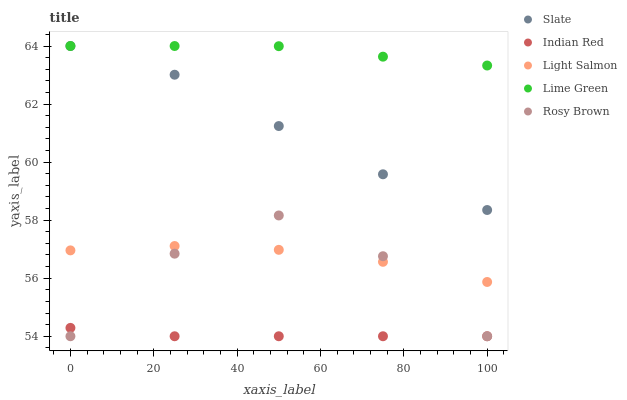Does Indian Red have the minimum area under the curve?
Answer yes or no. Yes. Does Lime Green have the maximum area under the curve?
Answer yes or no. Yes. Does Rosy Brown have the minimum area under the curve?
Answer yes or no. No. Does Rosy Brown have the maximum area under the curve?
Answer yes or no. No. Is Indian Red the smoothest?
Answer yes or no. Yes. Is Rosy Brown the roughest?
Answer yes or no. Yes. Is Lime Green the smoothest?
Answer yes or no. No. Is Lime Green the roughest?
Answer yes or no. No. Does Rosy Brown have the lowest value?
Answer yes or no. Yes. Does Lime Green have the lowest value?
Answer yes or no. No. Does Lime Green have the highest value?
Answer yes or no. Yes. Does Rosy Brown have the highest value?
Answer yes or no. No. Is Indian Red less than Lime Green?
Answer yes or no. Yes. Is Slate greater than Rosy Brown?
Answer yes or no. Yes. Does Slate intersect Lime Green?
Answer yes or no. Yes. Is Slate less than Lime Green?
Answer yes or no. No. Is Slate greater than Lime Green?
Answer yes or no. No. Does Indian Red intersect Lime Green?
Answer yes or no. No. 